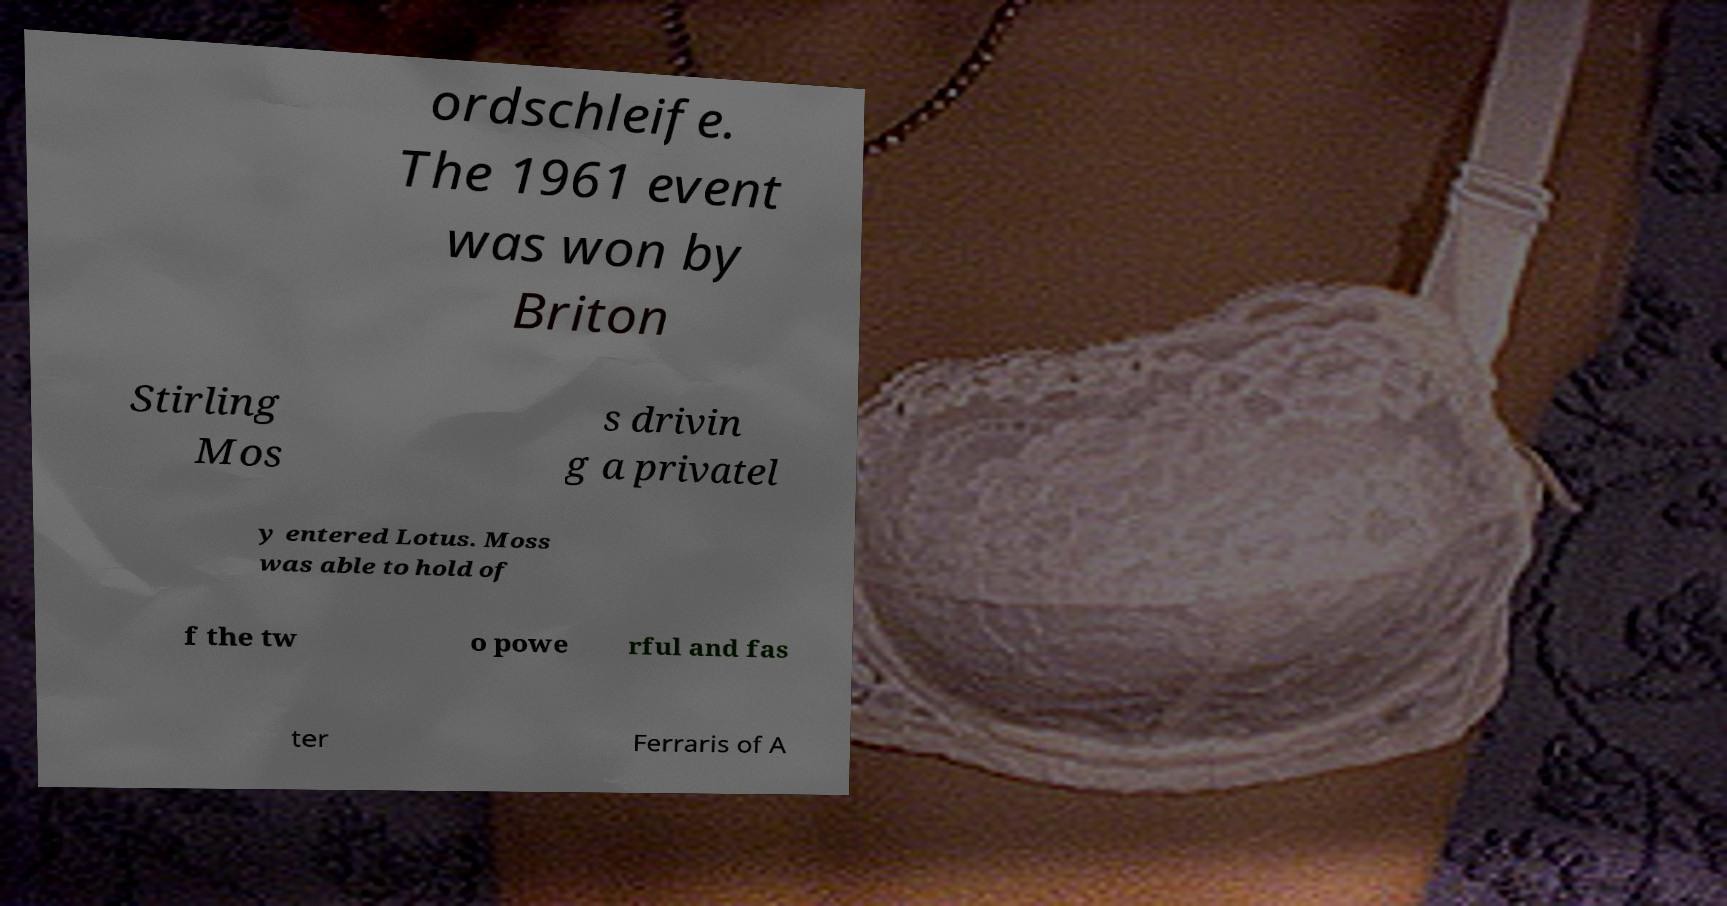Could you assist in decoding the text presented in this image and type it out clearly? ordschleife. The 1961 event was won by Briton Stirling Mos s drivin g a privatel y entered Lotus. Moss was able to hold of f the tw o powe rful and fas ter Ferraris of A 